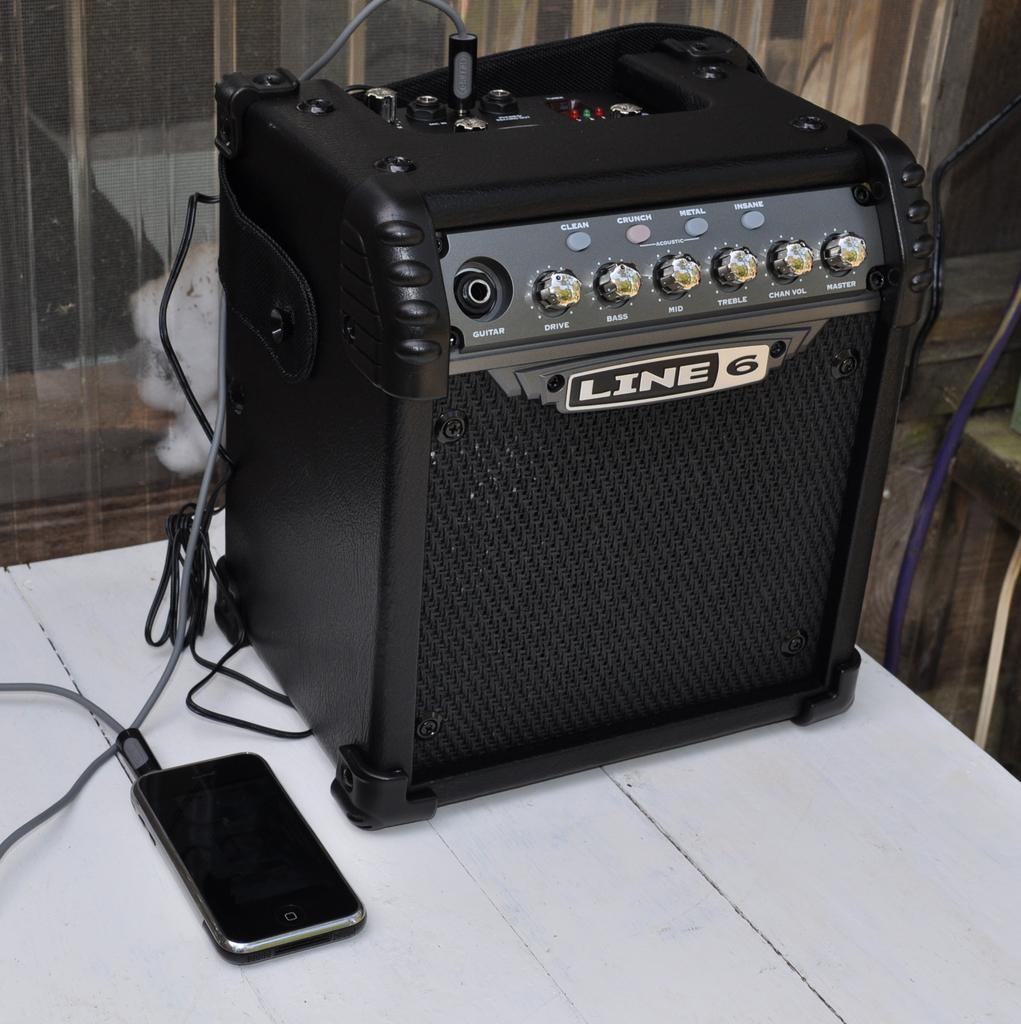<image>
Present a compact description of the photo's key features. The boom box shown is made by the company LINE. 